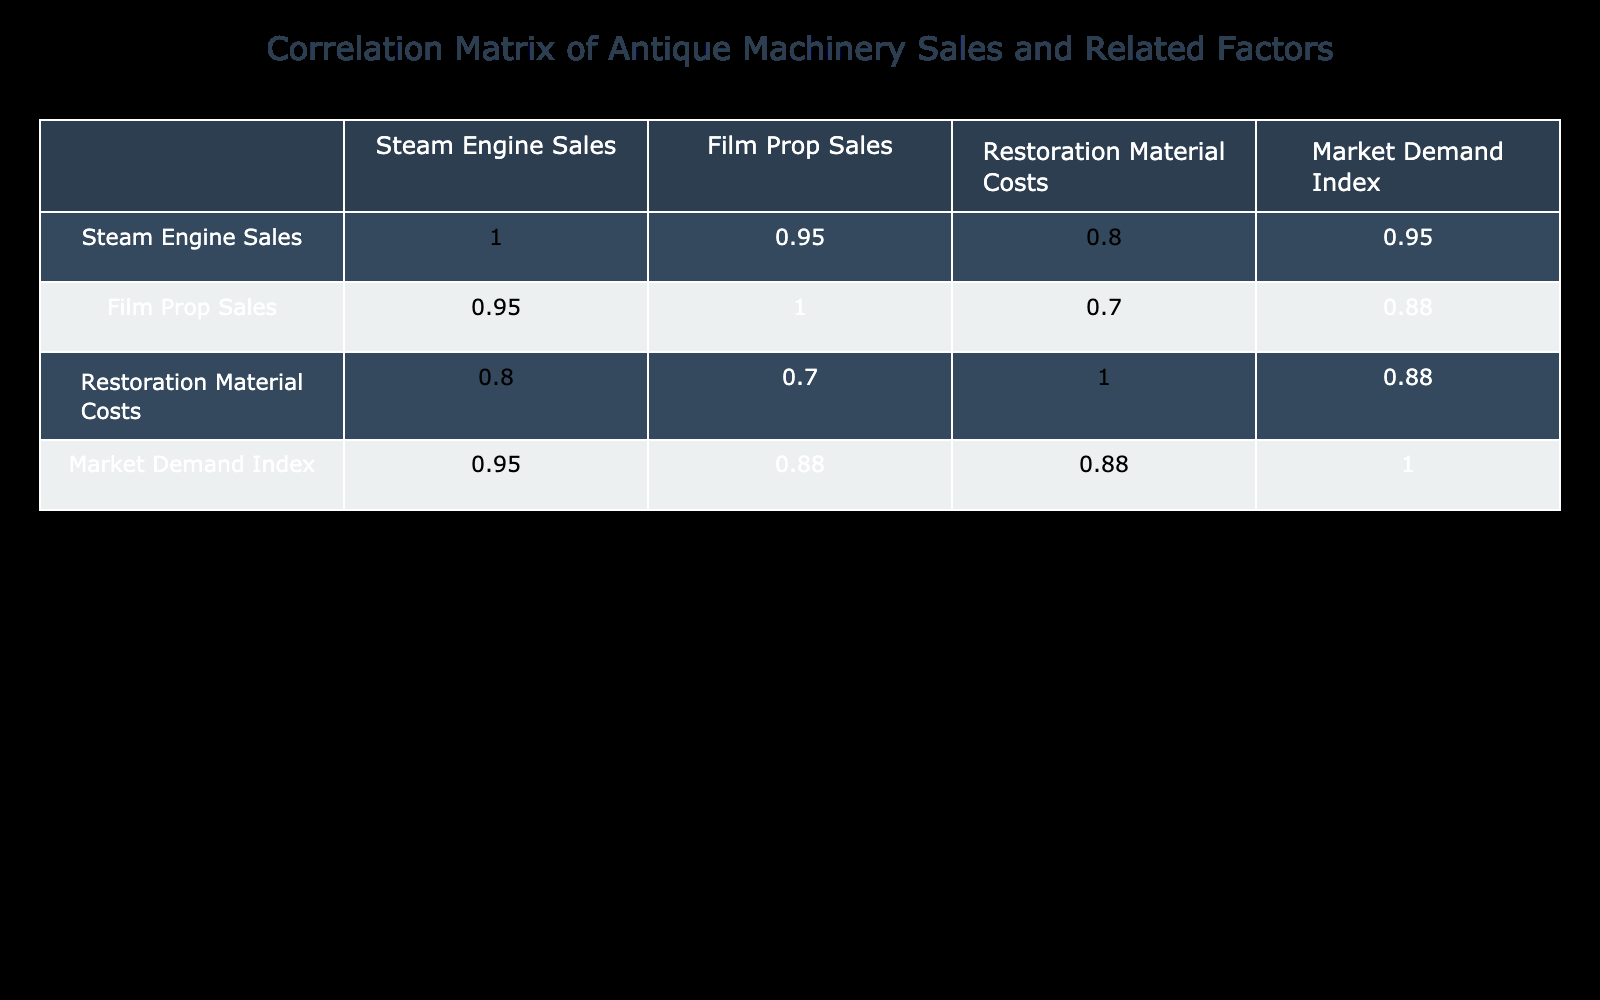What was the Steam Engine Sales in Q2 2023? The table shows Steam Engine Sales for Q2 2023 as 65 units.
Answer: 65 What is the correlation between Film Prop Sales and Market Demand Index? The correlation value from the table indicates a strong positive correlation of 0.98, suggesting that as Film Prop Sales increase, so does the Market Demand Index.
Answer: 0.98 What was the total Steam Engine Sales for 2022? The total for Steam Engine Sales in 2022 is the sum of sales from all four quarters: 50 + 60 + 70 + 80 = 260.
Answer: 260 Did the Restoration Material Costs decrease from Q4 2022 to Q1 2023? The table shows Restoration Material Costs were 14000 in Q4 2022 and decreased to 11000 in Q1 2023, indicating a decrease.
Answer: Yes What is the average Market Demand Index over the four quarters of 2023? To find the average Market Demand Index for 2023, we add the values (70 + 78 + 88 + 95) = 331 and divide by 4, giving us 331/4 = 82.75.
Answer: 82.75 Which quarter had the highest Film Prop Sales? Upon examining the table, Q4 2023 shows the highest Film Prop Sales at 70 units.
Answer: Q4 2023 Did Steam Engine Sales grow in every quarter of 2023 compared to the previous quarter? By reviewing the data, Q1 2023 had 55 sales followed by an increase to 65 in Q2, then 75 in Q3, and finally 85 in Q4, confirming consistent growth each quarter.
Answer: Yes What was the difference in Restoration Material Costs between Q3 2022 and Q2 2023? The Restoration Material Costs were 15000 in Q3 2022 and 12500 in Q2 2023. The difference is 15000 - 12500 = 2500.
Answer: 2500 Was the Market Demand Index in Q3 2022 higher than in Q1 2023? By checking the values, the Market Demand Index in Q3 2022 is 85 and in Q1 2023 it's 70, confirming that Q3 2022 was higher.
Answer: Yes 